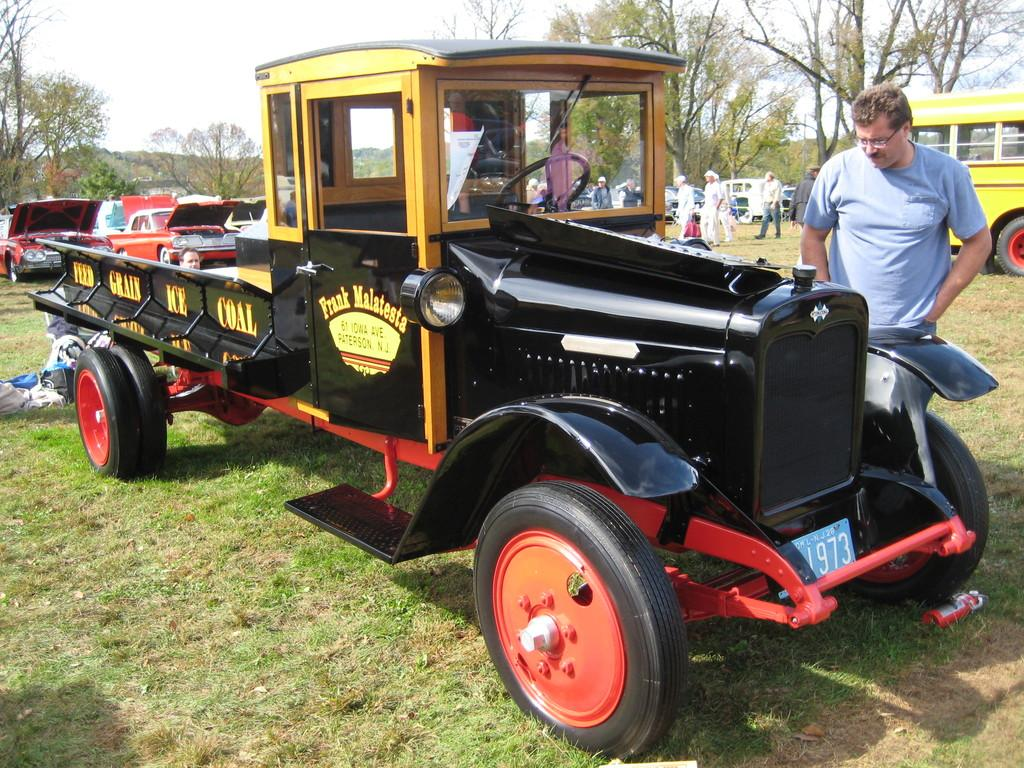What color is the vehicle in the image? The vehicle in the image is black-colored. Who is present on the right side of the image? A man is standing on the right side of the image. What can be seen in the background of the image? There are trees, cars, and people in the background of the image. What is visible at the top of the image? The sky is visible at the top of the image. What type of paper is the toad reading during dinner in the image? There is no toad or paper present in the image, nor is there any indication of a dinner setting. 